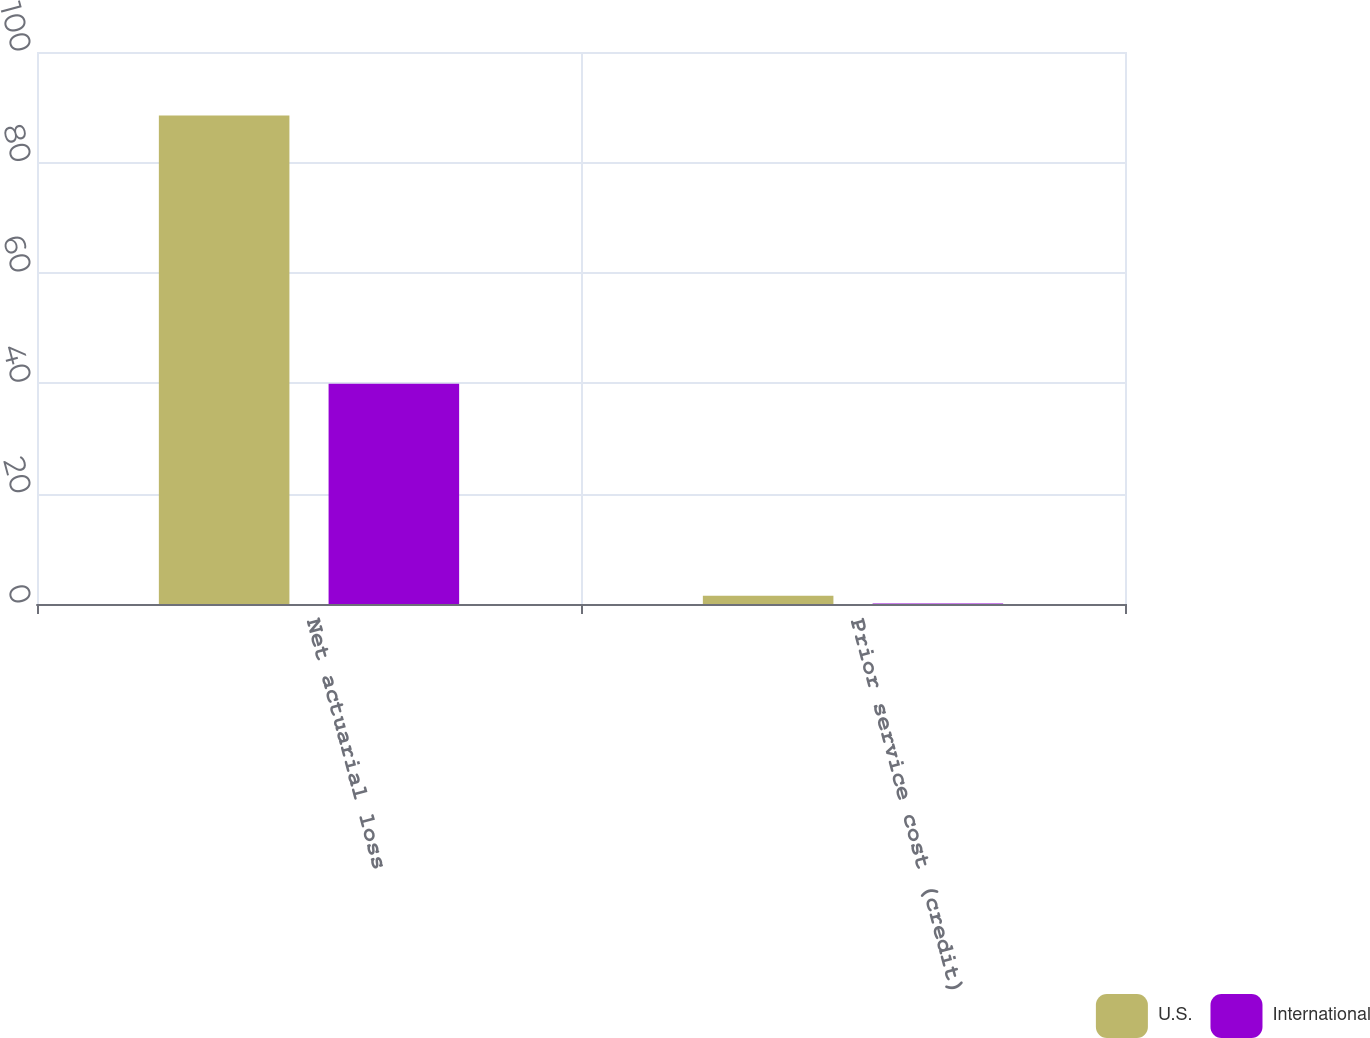Convert chart. <chart><loc_0><loc_0><loc_500><loc_500><stacked_bar_chart><ecel><fcel>Net actuarial loss<fcel>Prior service cost (credit)<nl><fcel>U.S.<fcel>88.5<fcel>1.5<nl><fcel>International<fcel>39.9<fcel>0.1<nl></chart> 